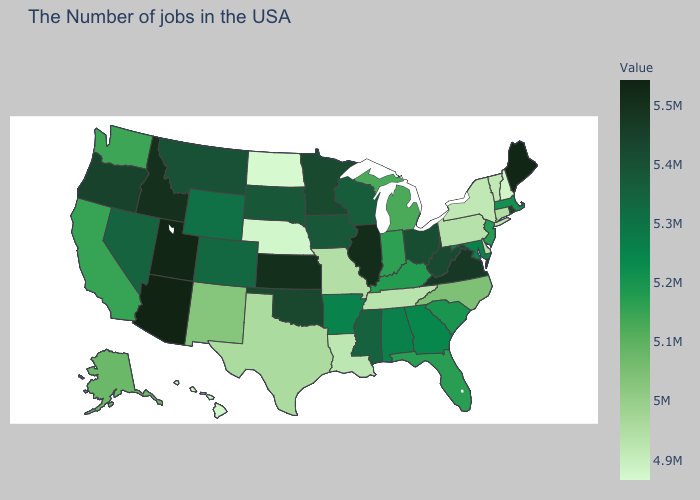Among the states that border Kansas , which have the lowest value?
Concise answer only. Nebraska. Which states have the highest value in the USA?
Concise answer only. Arizona. Is the legend a continuous bar?
Quick response, please. Yes. Does New Mexico have a lower value than Mississippi?
Concise answer only. Yes. Does Delaware have the highest value in the USA?
Quick response, please. No. Does Michigan have a higher value than Wisconsin?
Keep it brief. No. 